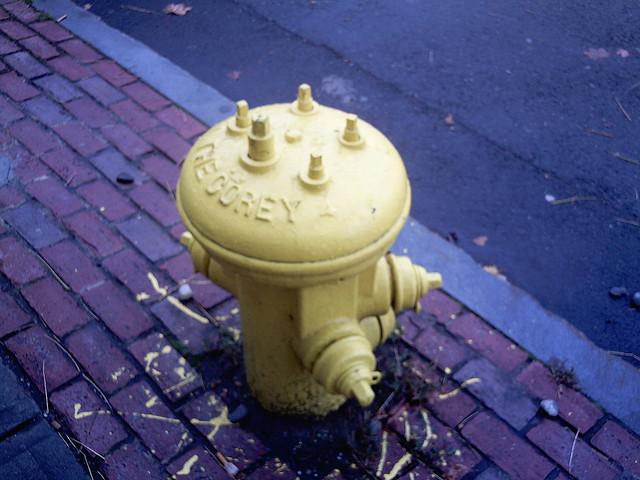How many nuts sticking out of the hydrant?
Be succinct. 5. Is the road made of bricks?
Answer briefly. No. What is the last letter on the word that's on the hydrant?
Answer briefly. Y. 